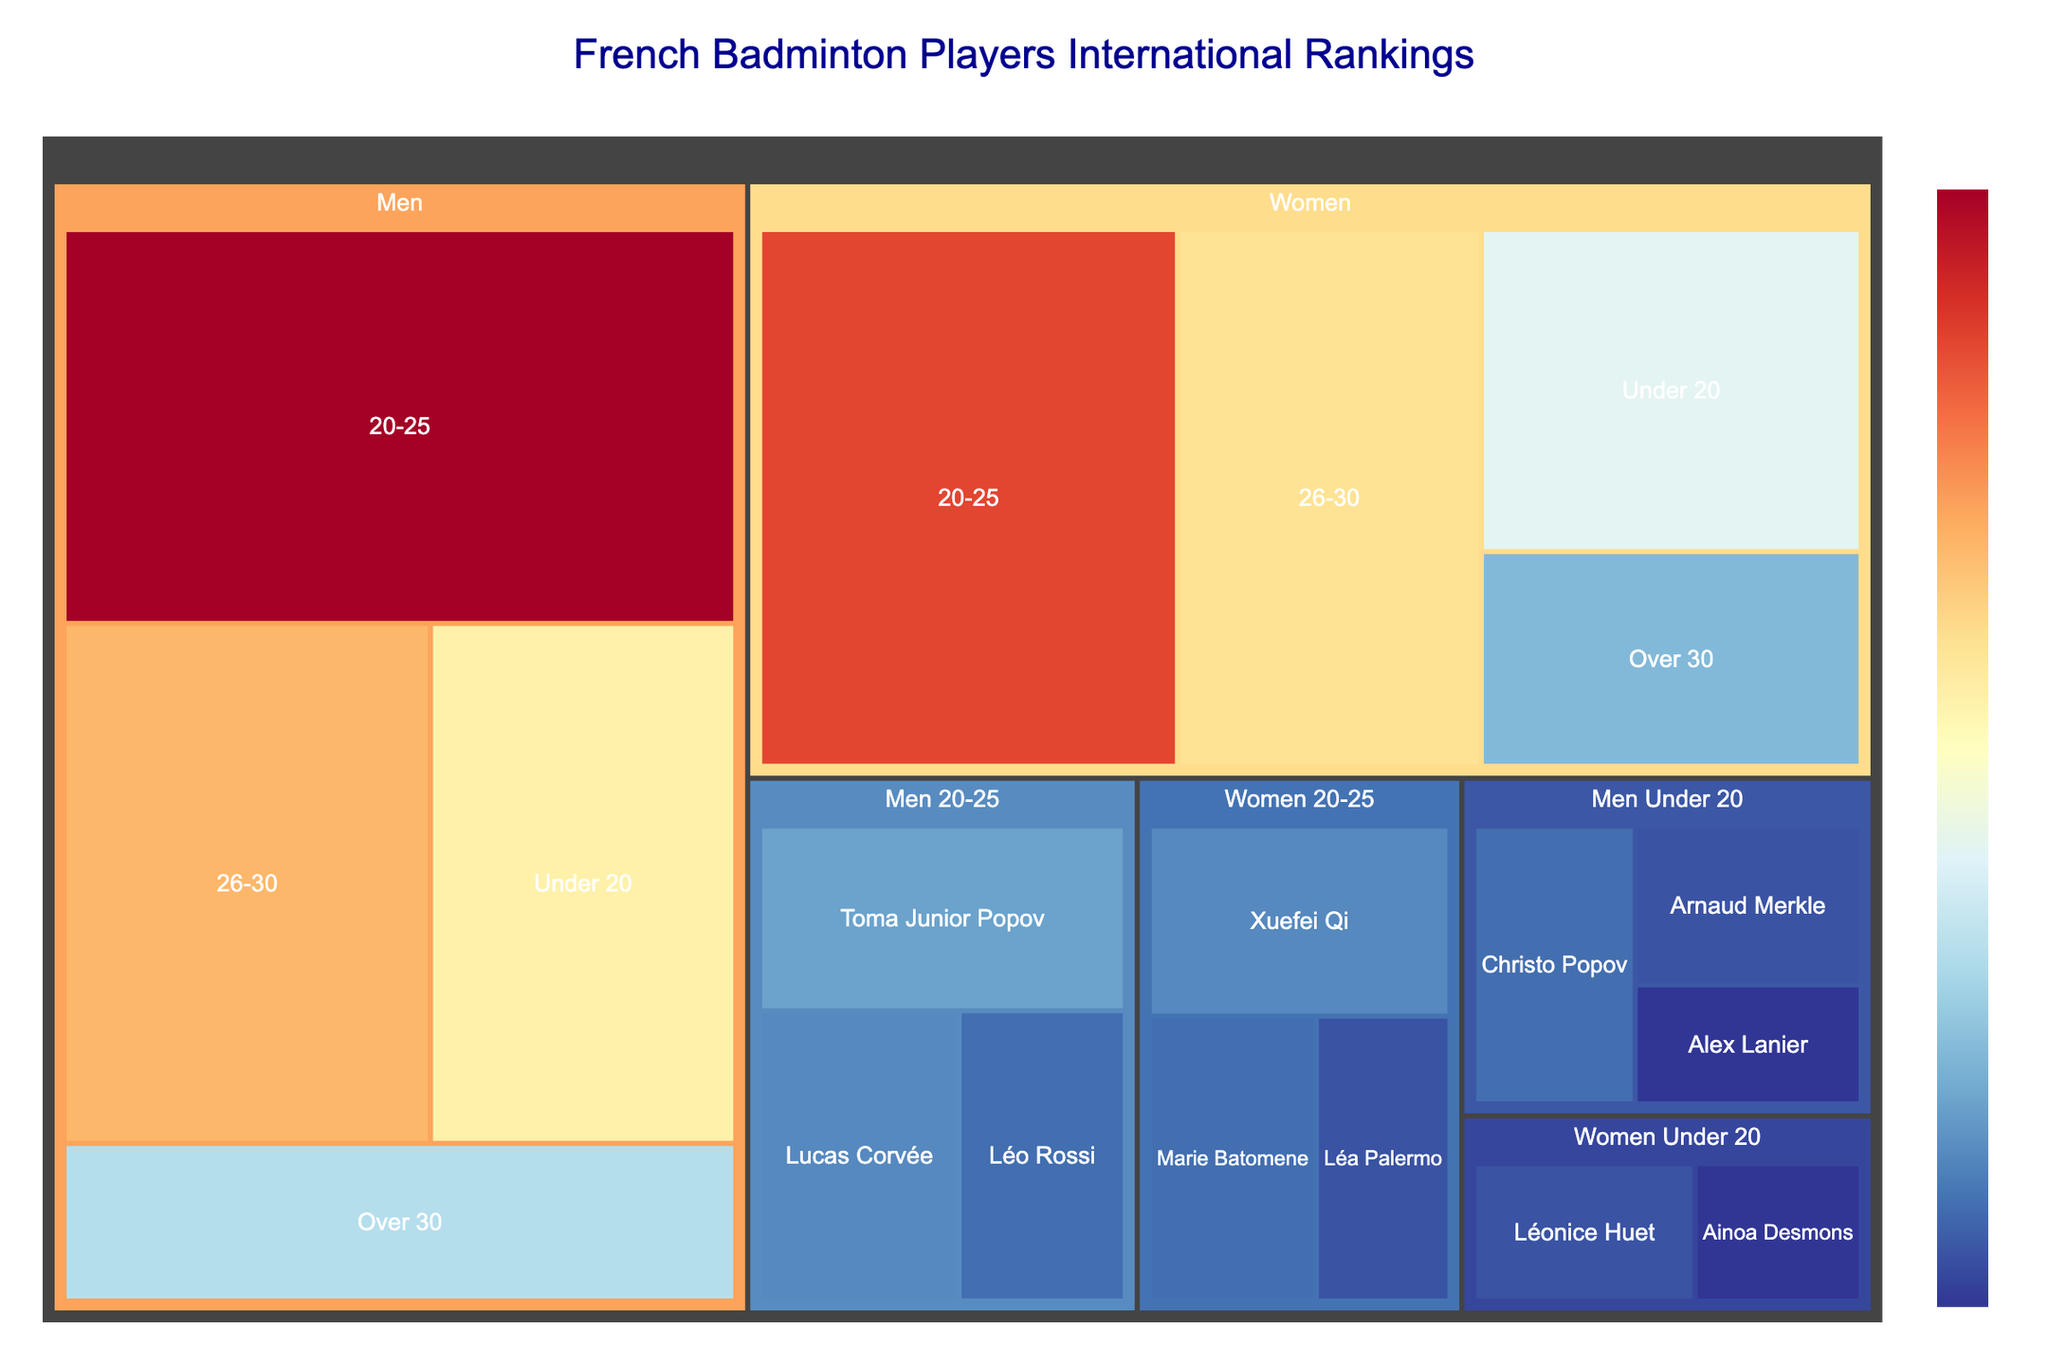What's the title of the figure? The title is usually displayed at the top of the figure, and it describes the main subject of the visualization. In this case, it summarizes the content of the treemap.
Answer: French Badminton Players International Rankings Which category has the most segments? By examining the treemap, you can see the number of individual segments under each primary category. Count the subcategories under each of Men and Women.
Answer: Men Which age group within the Men's category has the highest ranking value? The treemap shows different rectangles with their size representing the ranking value. Identify the largest rectangle within the Men's category.
Answer: 20-25 How many ranking points do Women over 30 years old have? Locate the rectangle for Women in the Over 30 subcategory and read its ranking value.
Answer: 8 Compare the ranking points of Men aged 26-30 with Women aged 26-30. Which group has more points? Find the rectangles for both age groups and compare their values; Men aged 26-30 have 18 points and Women aged 26-30 have 16 points.
Answer: Men aged 26-30 What is the total ranking value for Men in all age groups combined? Sum the ranking values for all the Men subcategories: Under 20 (15), 20-25 (25), 26-30 (18), Over 30 (10). Calculate 15 + 25 + 18 + 10.
Answer: 68 Who has the highest individual ranking value in the Men Under 20 subcategory? Look for the individuals listed under Men Under 20 and identify the highest value among them. Christo Popov has the highest value of 5.
Answer: Christo Popov Which individual has the highest ranking in the Women 20-25 subcategory? Examine the Women 20-25 subcategory for the individual with the highest ranking value. Xuefei Qi has a value of 6.
Answer: Xuefei Qi How many ranking points does Léonice Huet have? Locate the rectangle with Léonice Huet's name in the treemap and note the described ranking value.
Answer: 4 What's the average ranking value for the individuals listed under Men 20-25? Explain the steps involved. Identify the individual values: Toma Junior Popov (7), Lucas Corvée (6), and Léo Rossi (5). Sum the values: 7 + 6 + 5 = 18. Divide by the number of individuals (3).
Answer: 6 